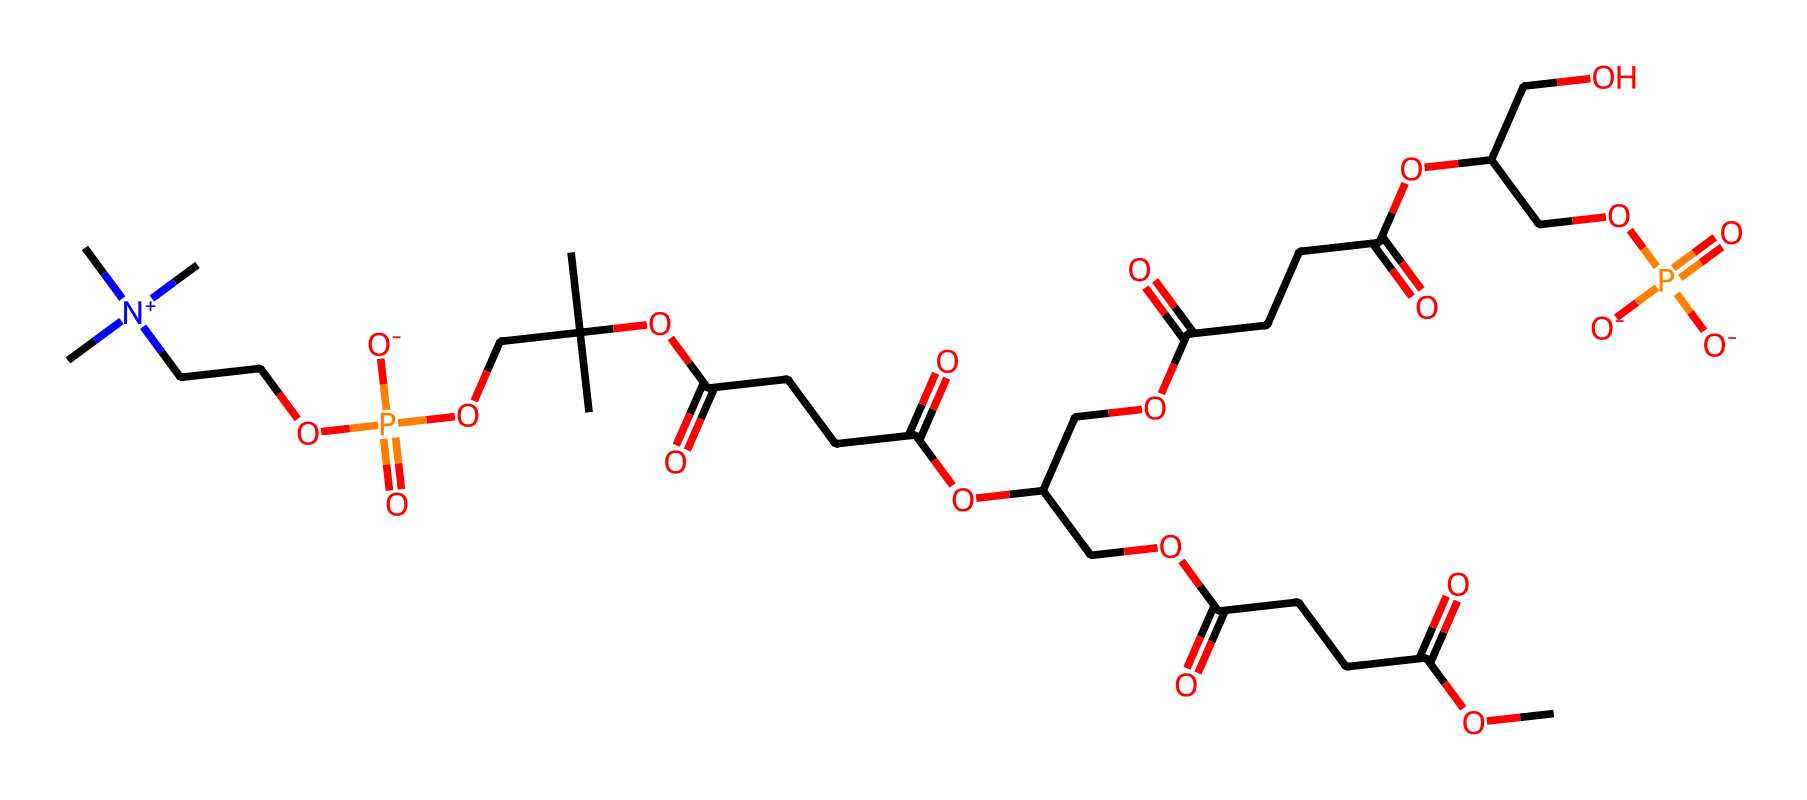What is the main functional group present in lecithin? The molecular structure shows multiple occurrences of a phosphate group (P=O), which indicates that it is a phospholipid. The presence of this phosphate group is characteristic of lecithin.
Answer: phosphate group How many carbon atoms are present in this structure? By analyzing the SMILES representation, we identify numerous "C" characters that represent carbon atoms. Counting them reveals there are 30 carbon atoms in total.
Answer: 30 What type of surfactant is lecithin classified as? Lecithin has both hydrophobic (fatty acid chains) and hydrophilic (phosphate group) components, classifying it as an amphiphilic surfactant.
Answer: amphiphilic How many ester bonds are present in lecithin's structure? Analyzing the structure, we can identify several ester functional groups characterized by the presence of carbonyls adjacent to oxygen atoms within the fatty acid linkages. Counting these, we find there are 4 ester bonds in the structure.
Answer: 4 What property does the presence of polar phosphate groups confer to lecithin? The polar phosphate groups allow lecithin to interact with both water and oil, enhancing its capacity as an emulsifier in food, which stabilizes mixtures of oil and water.
Answer: emulsifying ability 